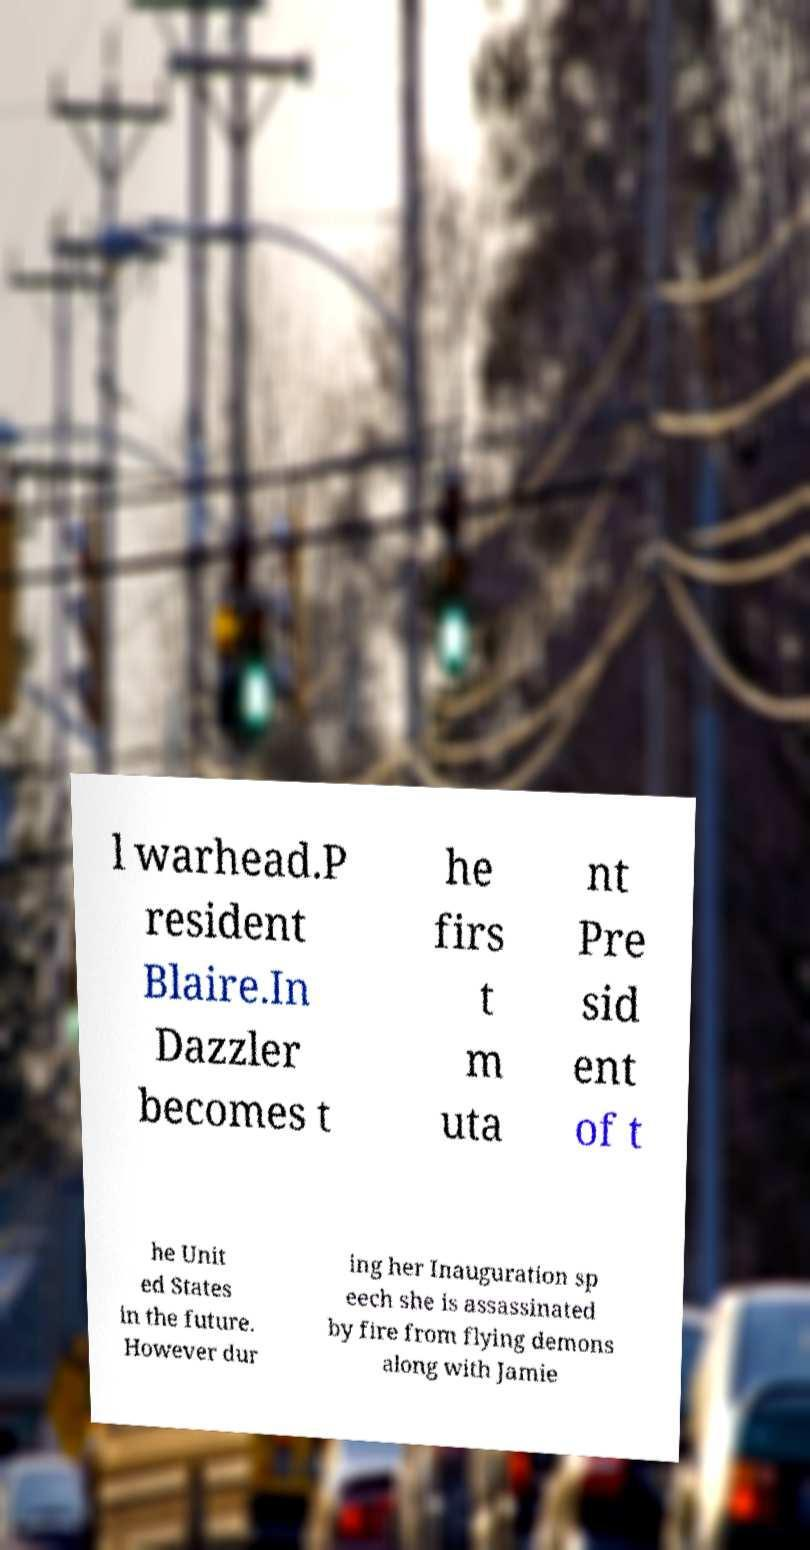I need the written content from this picture converted into text. Can you do that? l warhead.P resident Blaire.In Dazzler becomes t he firs t m uta nt Pre sid ent of t he Unit ed States in the future. However dur ing her Inauguration sp eech she is assassinated by fire from flying demons along with Jamie 